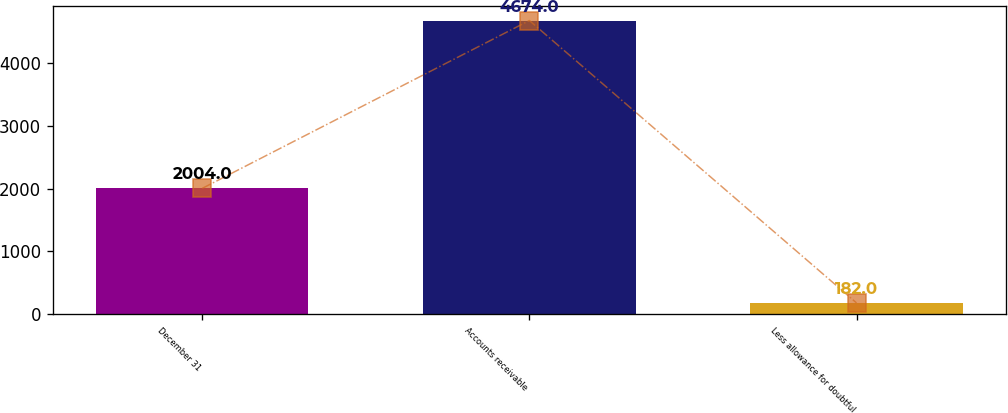Convert chart to OTSL. <chart><loc_0><loc_0><loc_500><loc_500><bar_chart><fcel>December 31<fcel>Accounts receivable<fcel>Less allowance for doubtful<nl><fcel>2004<fcel>4674<fcel>182<nl></chart> 